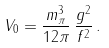Convert formula to latex. <formula><loc_0><loc_0><loc_500><loc_500>V _ { 0 } = \frac { m _ { \pi } ^ { 3 } } { 1 2 \pi } \, \frac { g ^ { 2 } } { f ^ { 2 } } \, .</formula> 